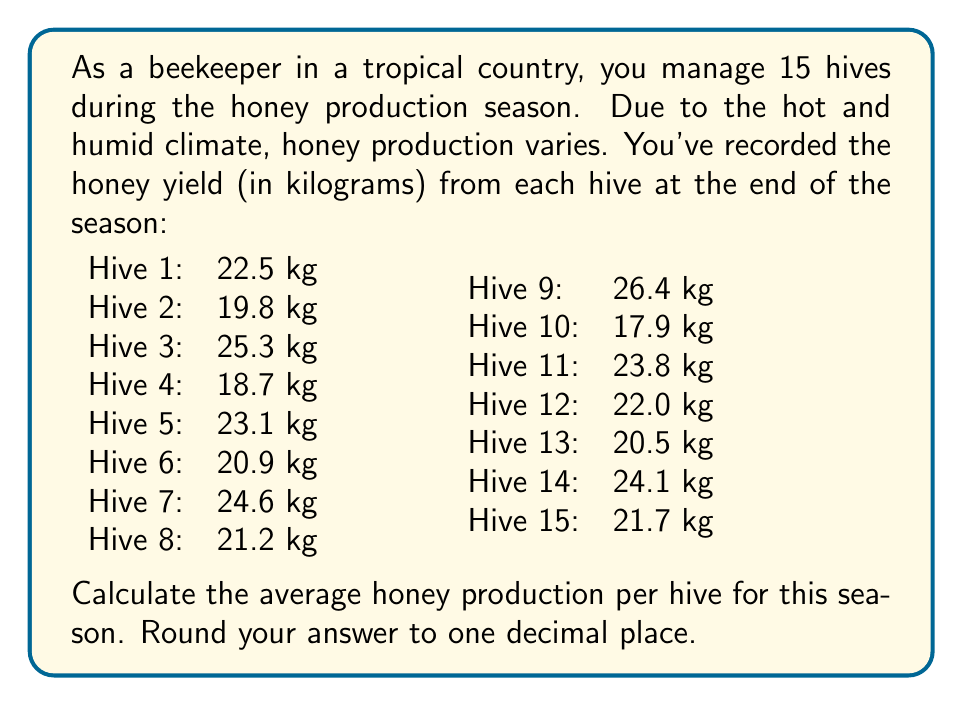Teach me how to tackle this problem. To calculate the average honey production per hive, we need to:

1. Sum up the total honey production from all hives
2. Divide the total by the number of hives

Let's go through these steps:

1. Sum of honey production:

$$ \text{Total Honey} = 22.5 + 19.8 + 25.3 + 18.7 + 23.1 + 20.9 + 24.6 + 21.2 + 26.4 + 17.9 + 23.8 + 22.0 + 20.5 + 24.1 + 21.7 $$

$$ \text{Total Honey} = 332.5 \text{ kg} $$

2. Calculate the average:

$$ \text{Average} = \frac{\text{Total Honey}}{\text{Number of Hives}} = \frac{332.5}{15} = 22.1666... \text{ kg} $$

Rounding to one decimal place:

$$ \text{Average} \approx 22.2 \text{ kg} $$
Answer: The average honey production per hive for this season is 22.2 kg. 